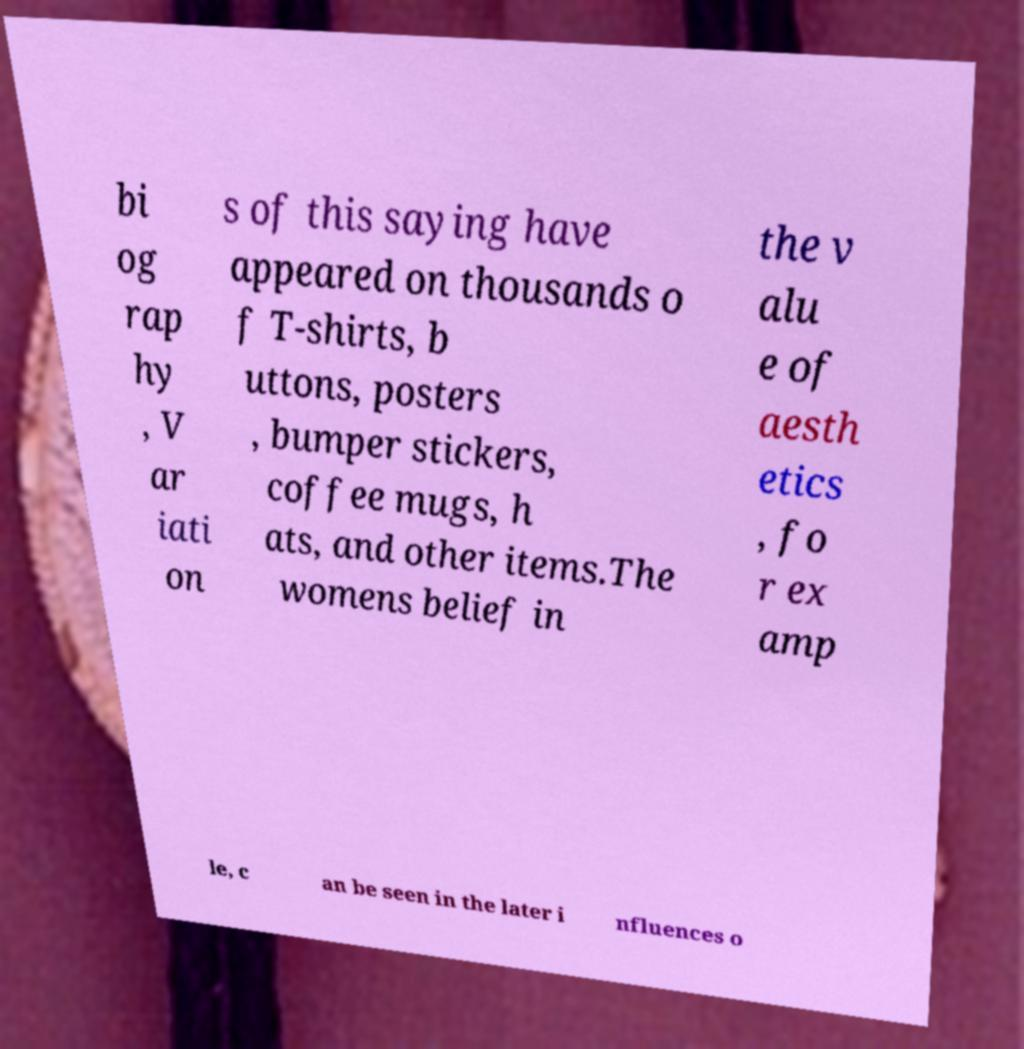Can you accurately transcribe the text from the provided image for me? bi og rap hy , V ar iati on s of this saying have appeared on thousands o f T-shirts, b uttons, posters , bumper stickers, coffee mugs, h ats, and other items.The womens belief in the v alu e of aesth etics , fo r ex amp le, c an be seen in the later i nfluences o 